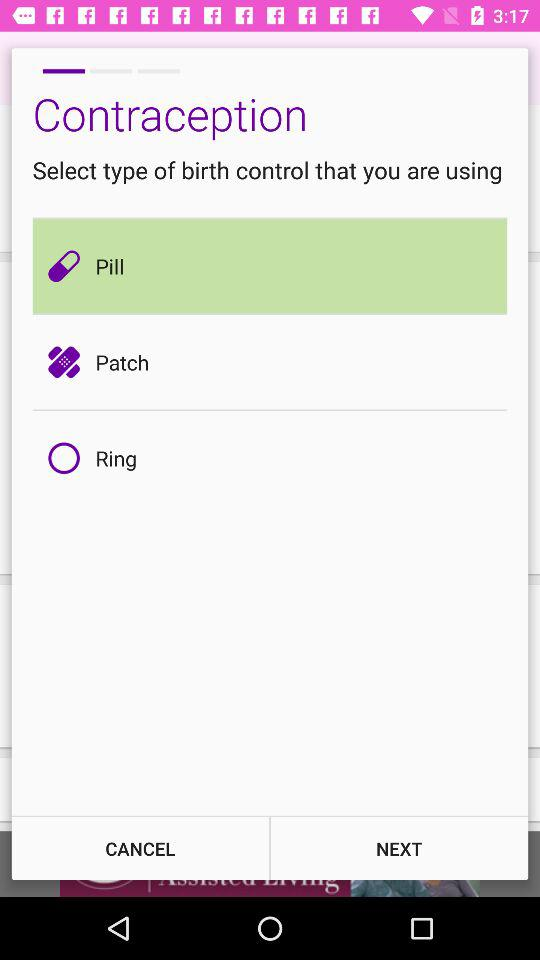How many contraceptive methods are available?
Answer the question using a single word or phrase. 3 